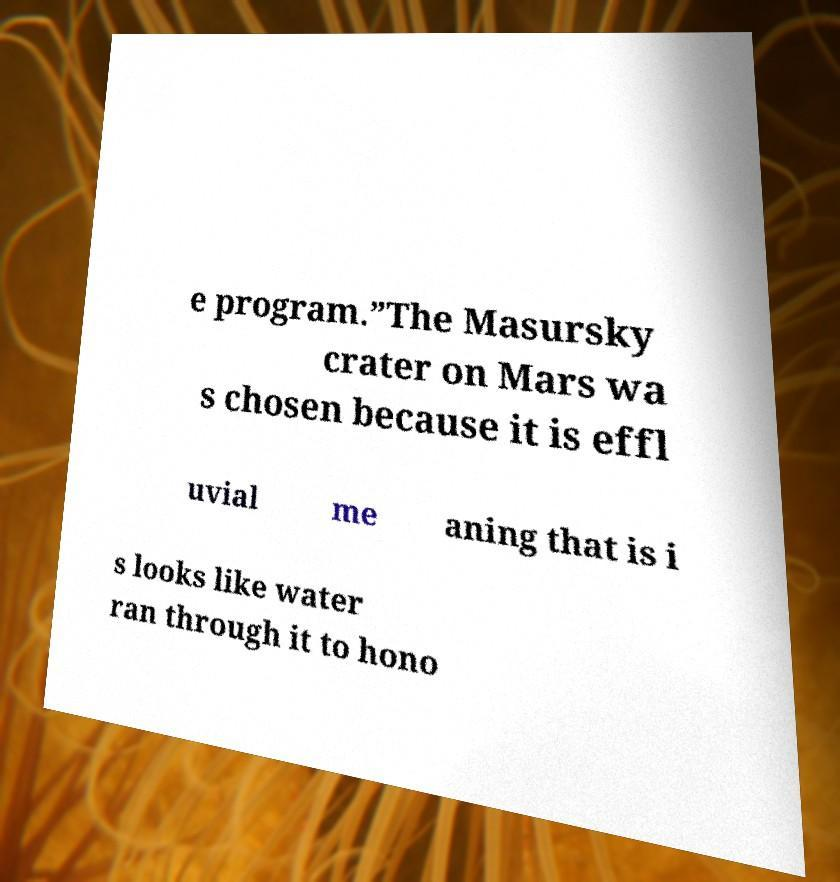Please identify and transcribe the text found in this image. e program.”The Masursky crater on Mars wa s chosen because it is effl uvial me aning that is i s looks like water ran through it to hono 